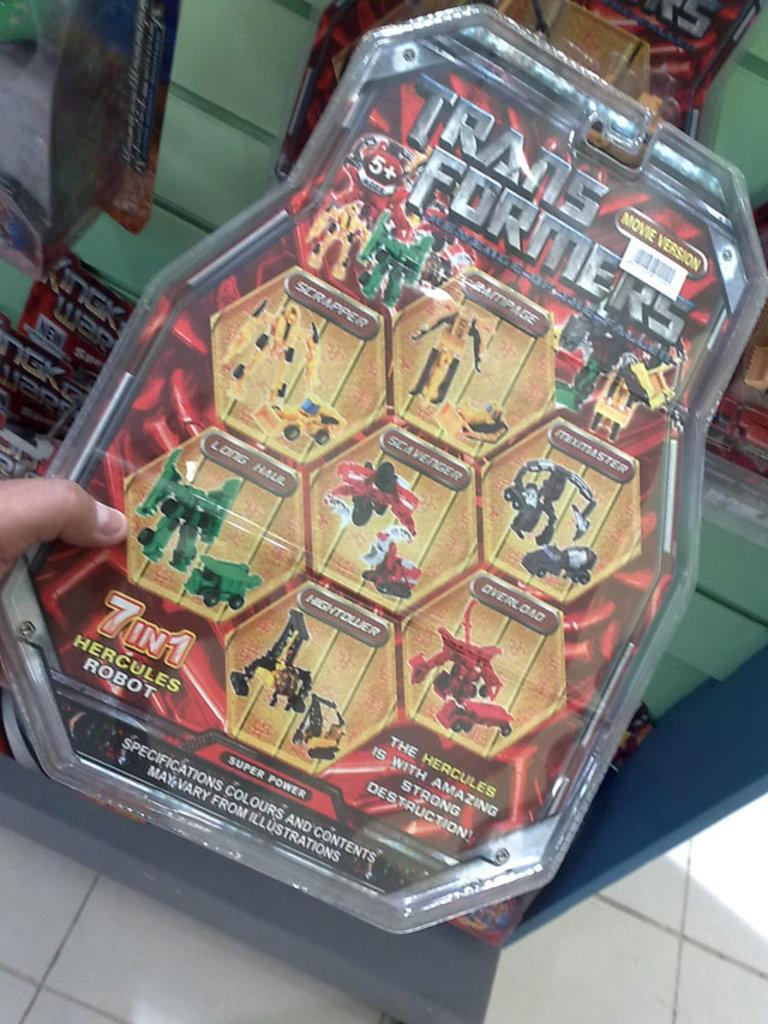What is the person in the image holding? The person is holding a playing object in the image. What can be seen at the bottom of the image? There is a floor visible at the bottom of the image. How many snails can be seen crawling on the net in the image? There is no net or snails present in the image. What type of damage can be seen on the floor due to the earthquake in the image? There is no earthquake or damage visible in the image; the floor appears to be undisturbed. 